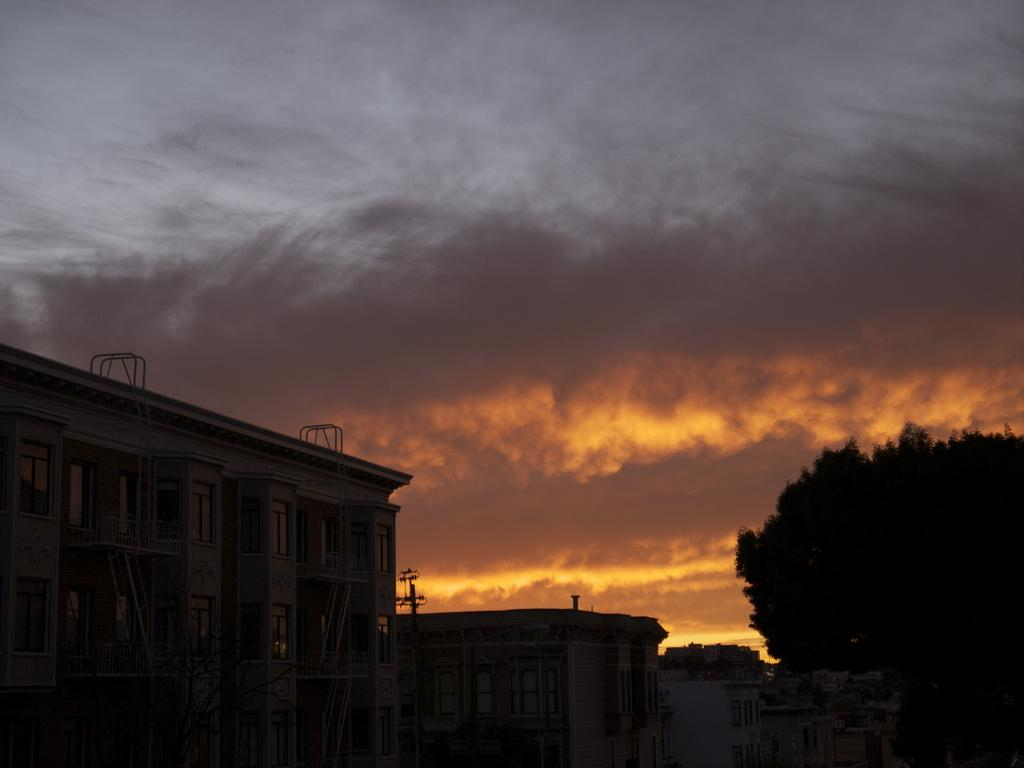What can be seen in the sky in the image? There is sky visible in the image. What type of structures are present in the image? There are buildings in the image. What type of vegetation is on the right side of the image? There is a tree towards the right side of the image. What is the pole used for in the image? The purpose of the pole is not clear from the image. What can be seen through the windows in the image? The contents of the rooms behind the windows cannot be determined from the image. Where is the basketball court located in the image? There is no basketball court present in the image. What type of wilderness can be seen in the background of the image? There is no wilderness visible in the image; it features buildings, a tree, and a pole. 